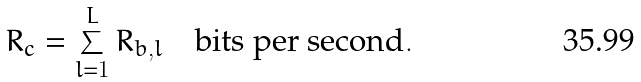Convert formula to latex. <formula><loc_0><loc_0><loc_500><loc_500>R _ { c } = \sum _ { l = 1 } ^ { L } R _ { b , l } \quad \text {bits per second} .</formula> 